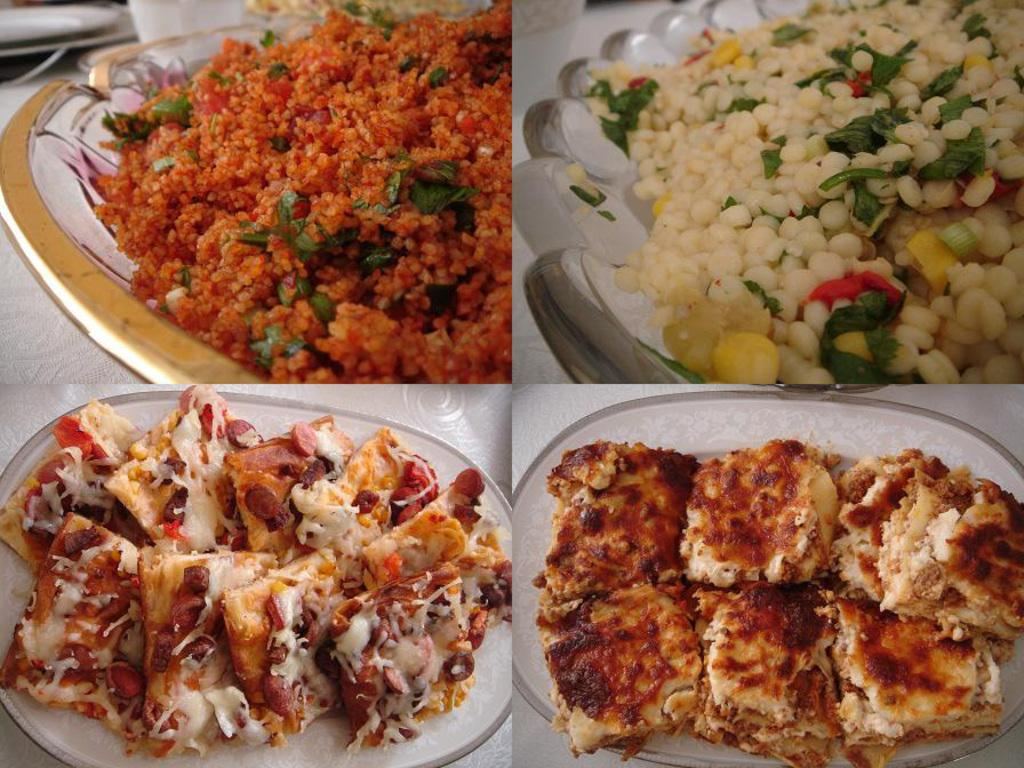What type of artwork is depicted in the image? The image is a collage. What can be seen on the plates in the image? There are food items on plates in the image. What is the color of the surface on which the plates are placed? The plates are placed on a white surface. What type of arm is visible in the image? There is no arm visible in the image; it is a collage of food items on plates placed on a white surface. 